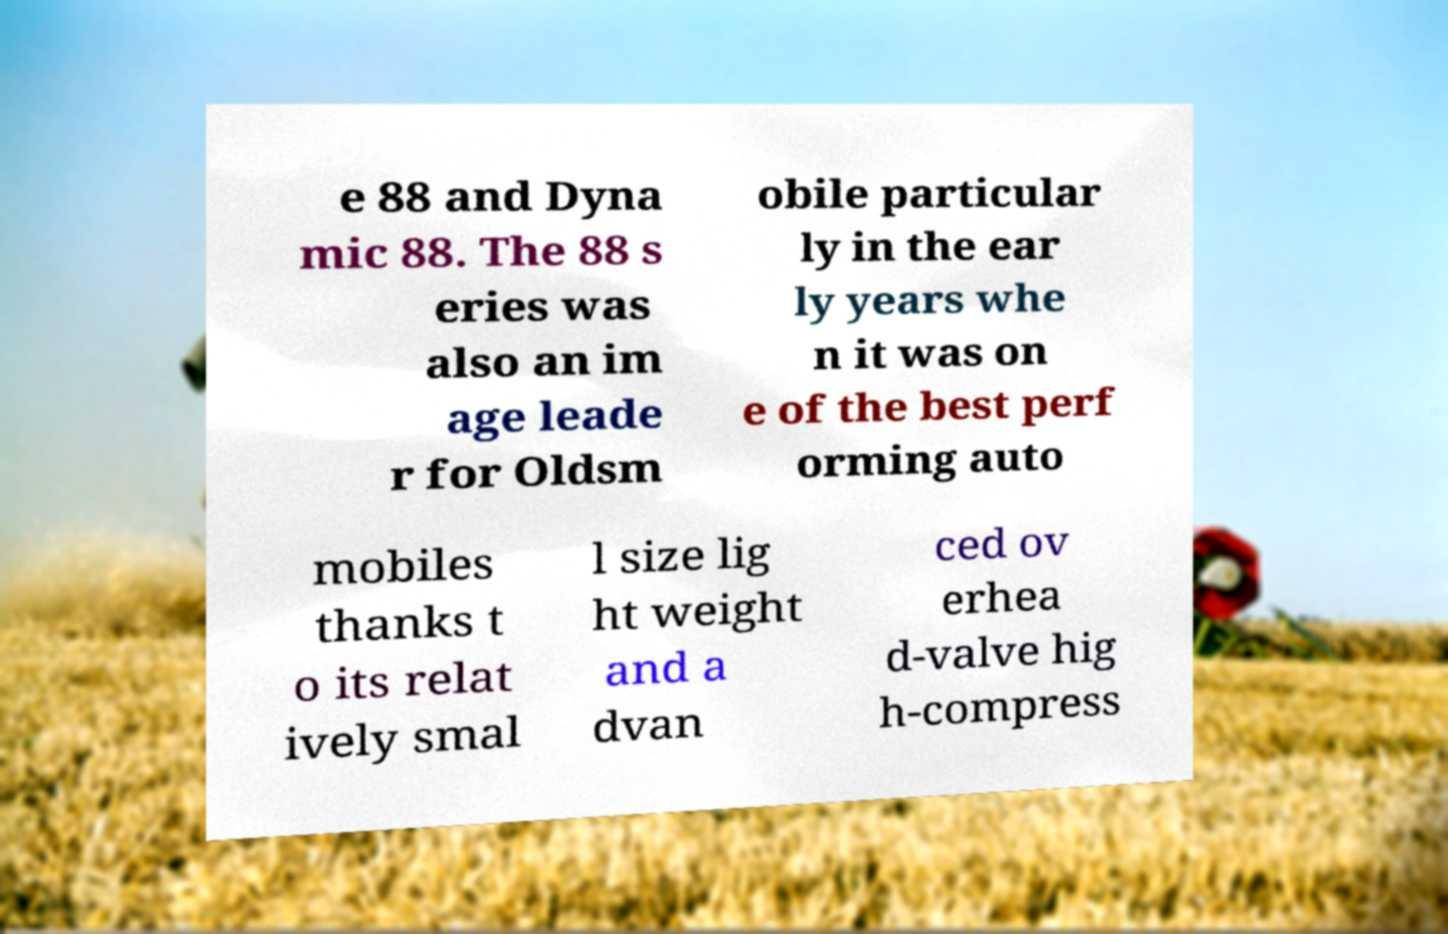Please identify and transcribe the text found in this image. e 88 and Dyna mic 88. The 88 s eries was also an im age leade r for Oldsm obile particular ly in the ear ly years whe n it was on e of the best perf orming auto mobiles thanks t o its relat ively smal l size lig ht weight and a dvan ced ov erhea d-valve hig h-compress 